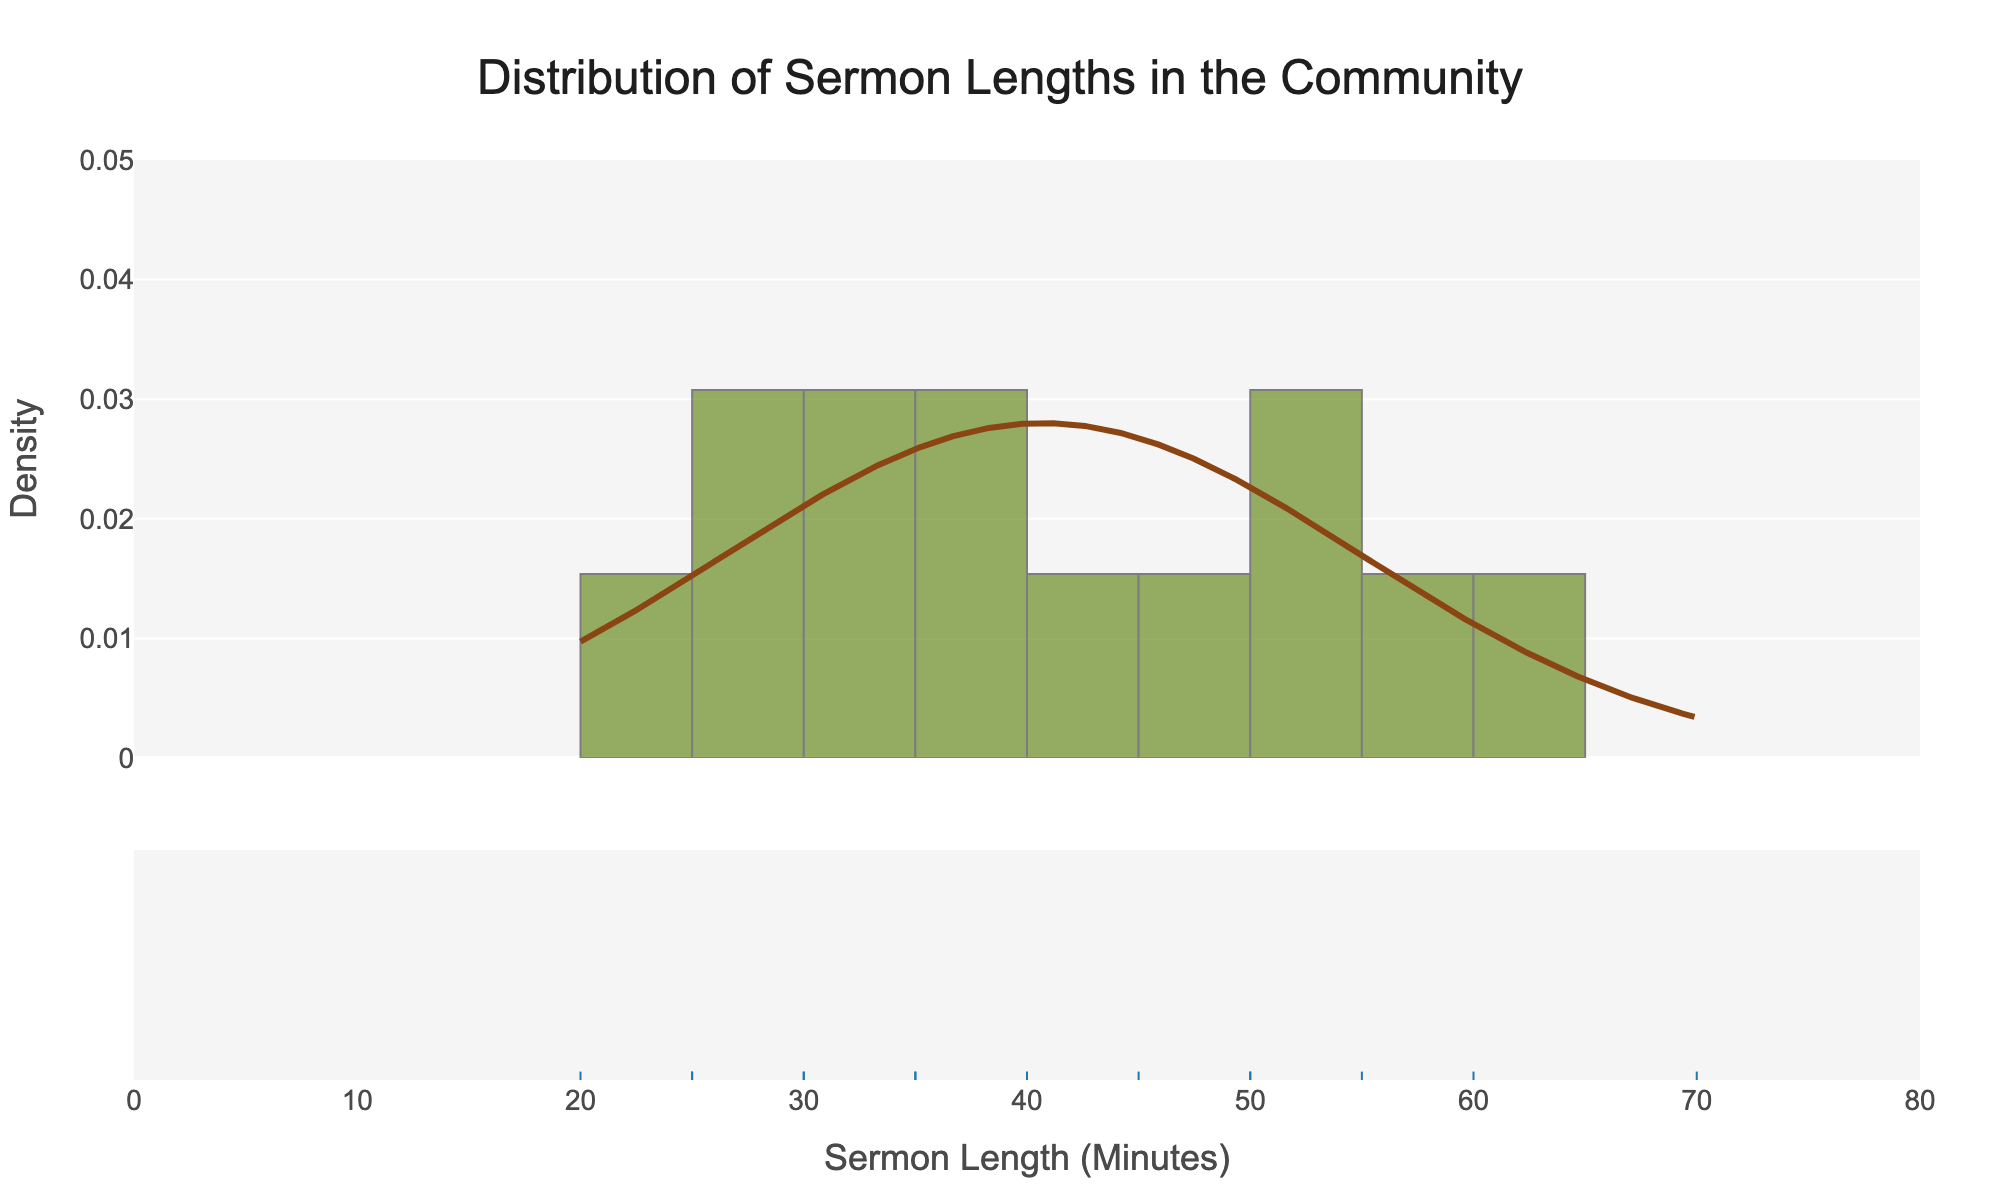What is the title of the figure? The title of the figure is at the top of the chart and typically stands out because it is larger and centered. The title helps understand the overall topic of the visualized data.
Answer: Distribution of Sermon Lengths in the Community What do the x-axis and y-axis represent? The x-axis represents the length of the sermons in minutes, while the y-axis represents the density of occurrences of these lengths. This information is located at the bottom (x-axis) and the side (y-axis) of the chart.
Answer: x-axis: Sermon Length (Minutes), y-axis: Density How many bins are used in the histogram? The histogram bins are segments along the x-axis where data points are grouped. You can count the segments between the x-axis ticks to determine the number of bins.
Answer: 14 What is the range of sermon lengths presented in the figure? By observing the x-axis, you can see the minimum and maximum values indicating the smallest and largest sermon lengths.
Answer: 20 to 70 minutes Which sermon length appears most frequently? The peak of the distribution curve indicates the most common sermon length. By identifying the highest point on the curve, you can determine this value.
Answer: Around 30 minutes Which pastor's sermon length is represented at the rightmost edge of the histogram? The rightmost edge of the histogram likely represents the highest sermon length, which can be cross-referenced with the data provided.
Answer: Pastor William Gonzalez Is there any visible trend in the sermon lengths delivered by various pastors? By examining the density curve and the histogram, you can identify any patterns or trends such as clusters or distributions of sermon lengths.
Answer: Most sermons are clustered around 30-50 minutes How does the 60-minute sermon length compare to other lengths in terms of frequency? Locate the 60-minute mark on the x-axis and observe the height of the histogram bins and density curve at this point. Compare it to the heights at other sermon lengths.
Answer: Less frequent than 30-50 minutes What color represents the density curve in the plot? Observe the color of the density line which is typically distinct and prominently visible in distplots.
Answer: Brown 